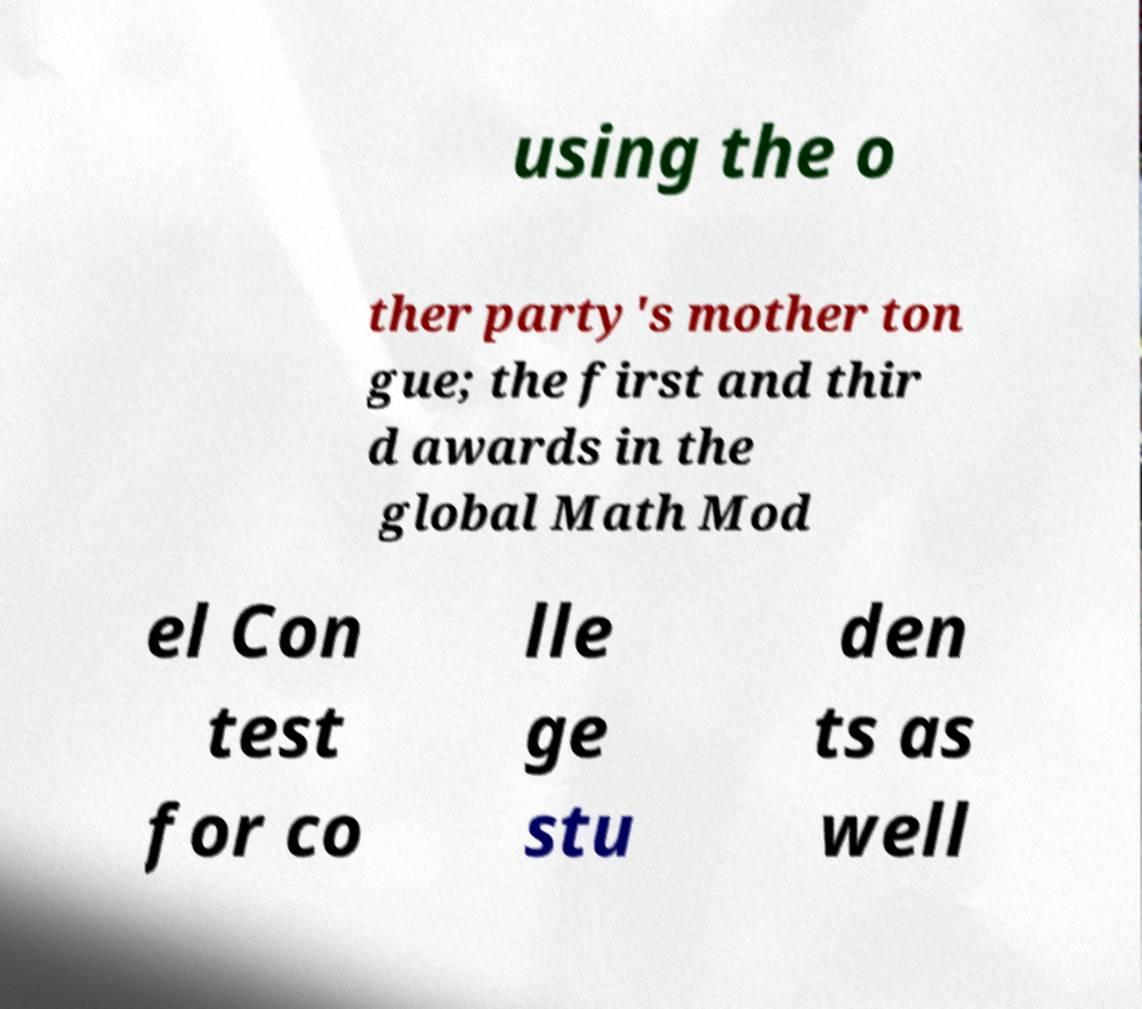Could you assist in decoding the text presented in this image and type it out clearly? using the o ther party's mother ton gue; the first and thir d awards in the global Math Mod el Con test for co lle ge stu den ts as well 